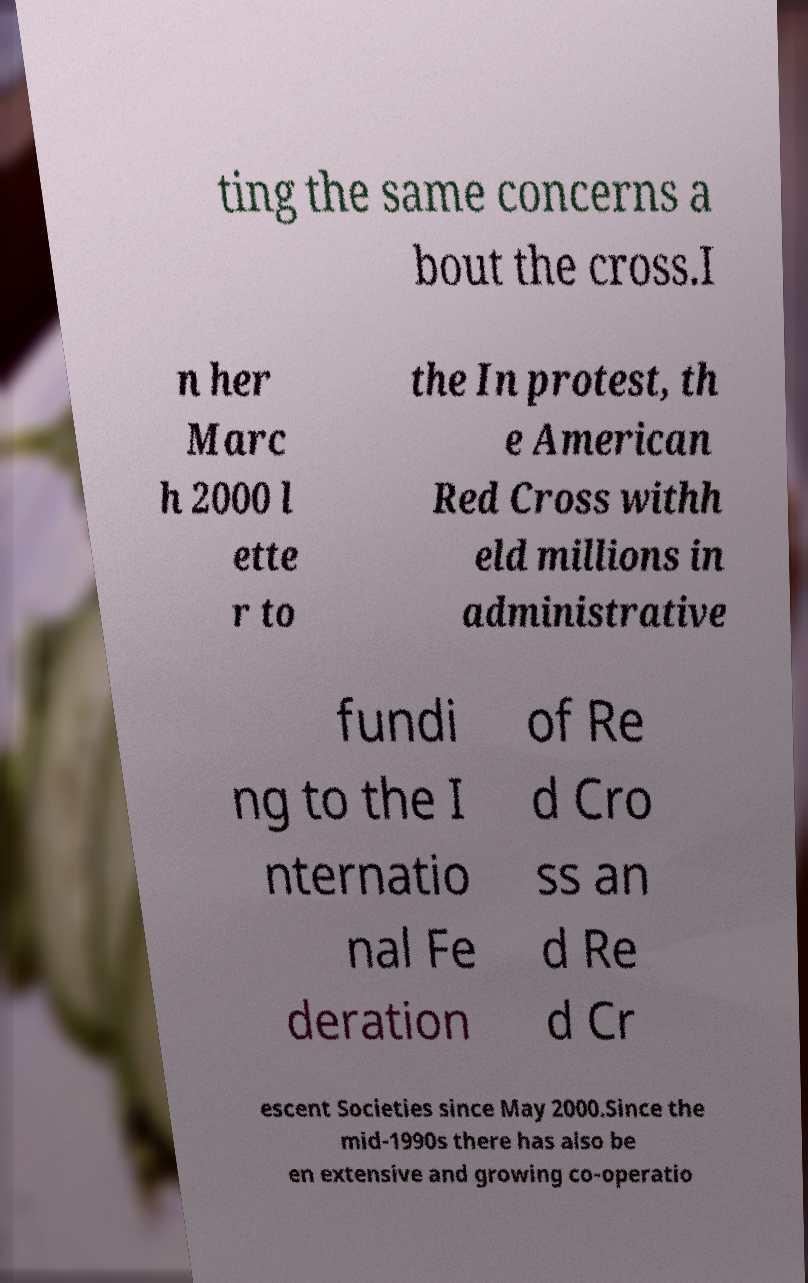For documentation purposes, I need the text within this image transcribed. Could you provide that? ting the same concerns a bout the cross.I n her Marc h 2000 l ette r to the In protest, th e American Red Cross withh eld millions in administrative fundi ng to the I nternatio nal Fe deration of Re d Cro ss an d Re d Cr escent Societies since May 2000.Since the mid-1990s there has also be en extensive and growing co-operatio 